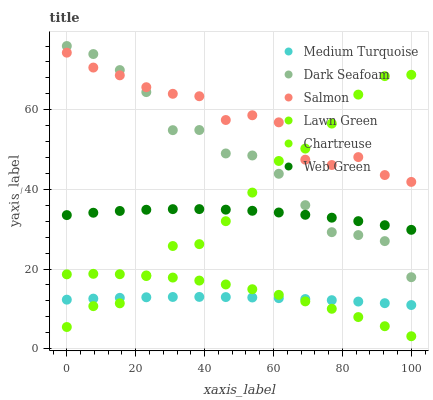Does Medium Turquoise have the minimum area under the curve?
Answer yes or no. Yes. Does Salmon have the maximum area under the curve?
Answer yes or no. Yes. Does Chartreuse have the minimum area under the curve?
Answer yes or no. No. Does Chartreuse have the maximum area under the curve?
Answer yes or no. No. Is Medium Turquoise the smoothest?
Answer yes or no. Yes. Is Dark Seafoam the roughest?
Answer yes or no. Yes. Is Salmon the smoothest?
Answer yes or no. No. Is Salmon the roughest?
Answer yes or no. No. Does Lawn Green have the lowest value?
Answer yes or no. Yes. Does Chartreuse have the lowest value?
Answer yes or no. No. Does Dark Seafoam have the highest value?
Answer yes or no. Yes. Does Salmon have the highest value?
Answer yes or no. No. Is Medium Turquoise less than Web Green?
Answer yes or no. Yes. Is Dark Seafoam greater than Medium Turquoise?
Answer yes or no. Yes. Does Dark Seafoam intersect Chartreuse?
Answer yes or no. Yes. Is Dark Seafoam less than Chartreuse?
Answer yes or no. No. Is Dark Seafoam greater than Chartreuse?
Answer yes or no. No. Does Medium Turquoise intersect Web Green?
Answer yes or no. No. 